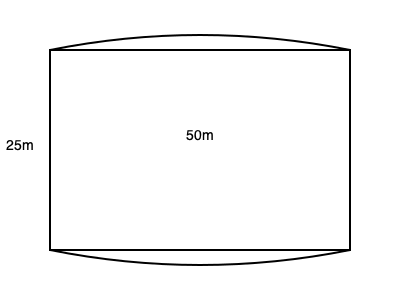In the 2024 Paris Olympics, a new irregularly shaped swimming pool is introduced. The pool has a rectangular base of 50m x 25m, but its ends are curved outwards. If the maximum curvature at each end increases the length by 2m, estimate the total surface area of the pool in square meters. To estimate the area of this irregularly shaped Olympic swimming pool, we'll follow these steps:

1. Calculate the area of the rectangular base:
   $A_{rectangle} = 50m \times 25m = 1250m^2$

2. Estimate the additional area due to the curved ends:
   - The curvature adds 2m to each end, so we can approximate it as two semi-circles.
   - The radius of each semi-circle would be half the width: $r = 25m \div 2 = 12.5m$
   - Area of a semi-circle: $A_{semi} = \frac{1}{2} \pi r^2$
   - Area of two semi-circles: $A_{curves} = \pi r^2 = \pi (12.5m)^2 \approx 490.87m^2$

3. Calculate the total estimated area:
   $A_{total} = A_{rectangle} + A_{curves}$
   $A_{total} = 1250m^2 + 490.87m^2 \approx 1740.87m^2$

4. Round to a reasonable precision for an estimate:
   $A_{total} \approx 1741m^2$

This method provides a good estimate of the pool's surface area, accounting for the curved ends while maintaining analytical rigor suitable for an Olympic historian's perspective.
Answer: $1741m^2$ 